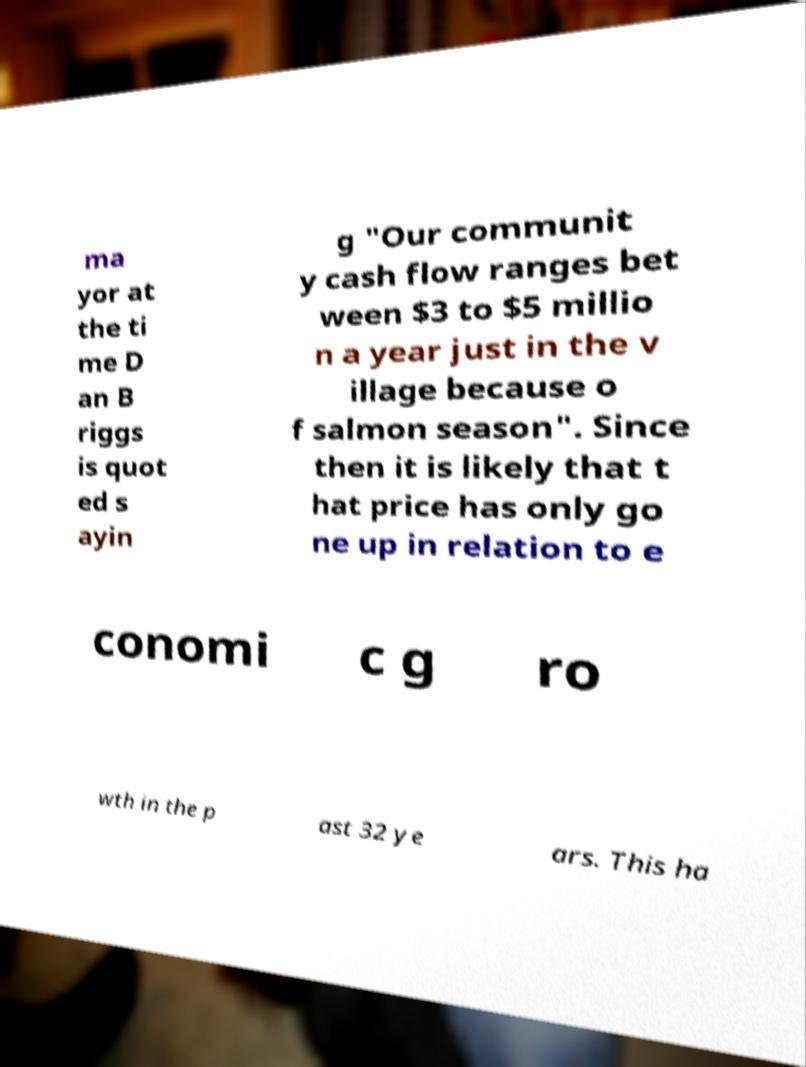Please identify and transcribe the text found in this image. ma yor at the ti me D an B riggs is quot ed s ayin g "Our communit y cash flow ranges bet ween $3 to $5 millio n a year just in the v illage because o f salmon season". Since then it is likely that t hat price has only go ne up in relation to e conomi c g ro wth in the p ast 32 ye ars. This ha 